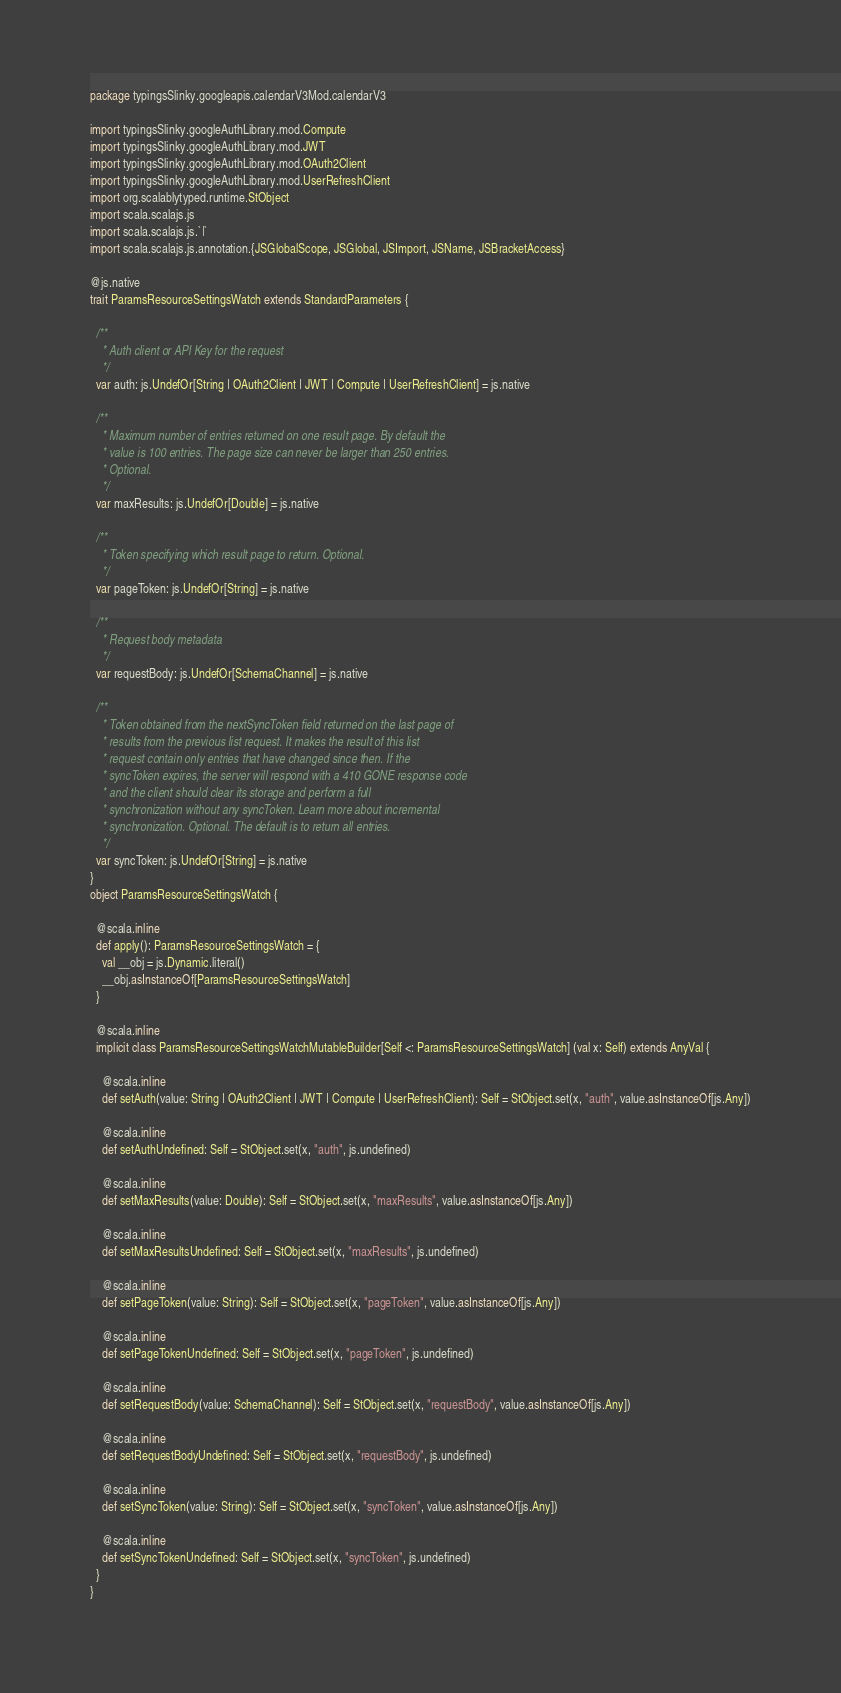Convert code to text. <code><loc_0><loc_0><loc_500><loc_500><_Scala_>package typingsSlinky.googleapis.calendarV3Mod.calendarV3

import typingsSlinky.googleAuthLibrary.mod.Compute
import typingsSlinky.googleAuthLibrary.mod.JWT
import typingsSlinky.googleAuthLibrary.mod.OAuth2Client
import typingsSlinky.googleAuthLibrary.mod.UserRefreshClient
import org.scalablytyped.runtime.StObject
import scala.scalajs.js
import scala.scalajs.js.`|`
import scala.scalajs.js.annotation.{JSGlobalScope, JSGlobal, JSImport, JSName, JSBracketAccess}

@js.native
trait ParamsResourceSettingsWatch extends StandardParameters {
  
  /**
    * Auth client or API Key for the request
    */
  var auth: js.UndefOr[String | OAuth2Client | JWT | Compute | UserRefreshClient] = js.native
  
  /**
    * Maximum number of entries returned on one result page. By default the
    * value is 100 entries. The page size can never be larger than 250 entries.
    * Optional.
    */
  var maxResults: js.UndefOr[Double] = js.native
  
  /**
    * Token specifying which result page to return. Optional.
    */
  var pageToken: js.UndefOr[String] = js.native
  
  /**
    * Request body metadata
    */
  var requestBody: js.UndefOr[SchemaChannel] = js.native
  
  /**
    * Token obtained from the nextSyncToken field returned on the last page of
    * results from the previous list request. It makes the result of this list
    * request contain only entries that have changed since then. If the
    * syncToken expires, the server will respond with a 410 GONE response code
    * and the client should clear its storage and perform a full
    * synchronization without any syncToken. Learn more about incremental
    * synchronization. Optional. The default is to return all entries.
    */
  var syncToken: js.UndefOr[String] = js.native
}
object ParamsResourceSettingsWatch {
  
  @scala.inline
  def apply(): ParamsResourceSettingsWatch = {
    val __obj = js.Dynamic.literal()
    __obj.asInstanceOf[ParamsResourceSettingsWatch]
  }
  
  @scala.inline
  implicit class ParamsResourceSettingsWatchMutableBuilder[Self <: ParamsResourceSettingsWatch] (val x: Self) extends AnyVal {
    
    @scala.inline
    def setAuth(value: String | OAuth2Client | JWT | Compute | UserRefreshClient): Self = StObject.set(x, "auth", value.asInstanceOf[js.Any])
    
    @scala.inline
    def setAuthUndefined: Self = StObject.set(x, "auth", js.undefined)
    
    @scala.inline
    def setMaxResults(value: Double): Self = StObject.set(x, "maxResults", value.asInstanceOf[js.Any])
    
    @scala.inline
    def setMaxResultsUndefined: Self = StObject.set(x, "maxResults", js.undefined)
    
    @scala.inline
    def setPageToken(value: String): Self = StObject.set(x, "pageToken", value.asInstanceOf[js.Any])
    
    @scala.inline
    def setPageTokenUndefined: Self = StObject.set(x, "pageToken", js.undefined)
    
    @scala.inline
    def setRequestBody(value: SchemaChannel): Self = StObject.set(x, "requestBody", value.asInstanceOf[js.Any])
    
    @scala.inline
    def setRequestBodyUndefined: Self = StObject.set(x, "requestBody", js.undefined)
    
    @scala.inline
    def setSyncToken(value: String): Self = StObject.set(x, "syncToken", value.asInstanceOf[js.Any])
    
    @scala.inline
    def setSyncTokenUndefined: Self = StObject.set(x, "syncToken", js.undefined)
  }
}
</code> 